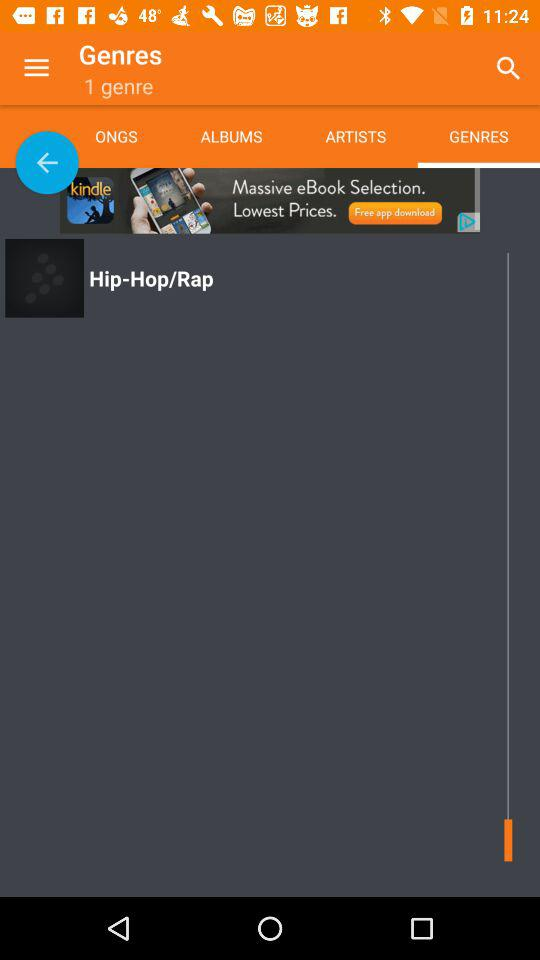How many genres are given? There is 1 genre given. 